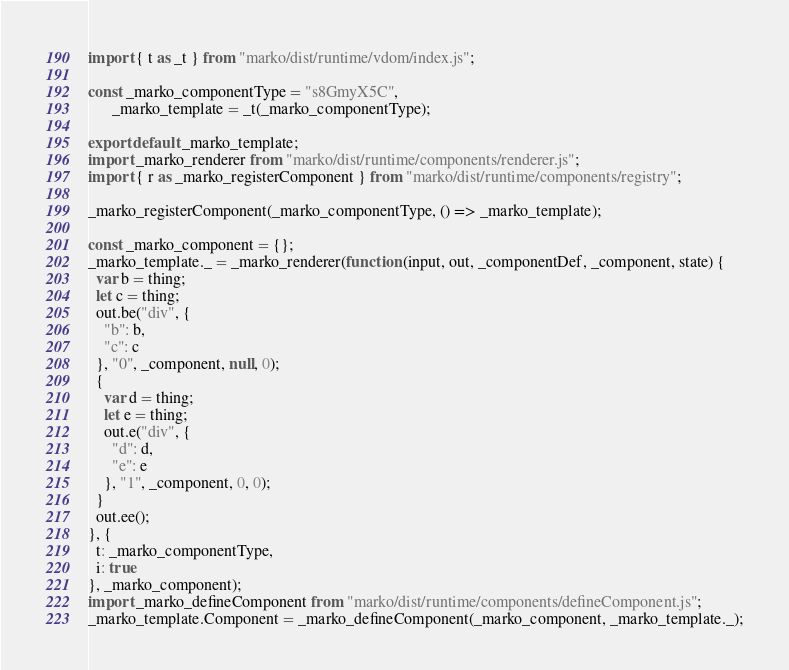Convert code to text. <code><loc_0><loc_0><loc_500><loc_500><_JavaScript_>import { t as _t } from "marko/dist/runtime/vdom/index.js";

const _marko_componentType = "s8GmyX5C",
      _marko_template = _t(_marko_componentType);

export default _marko_template;
import _marko_renderer from "marko/dist/runtime/components/renderer.js";
import { r as _marko_registerComponent } from "marko/dist/runtime/components/registry";

_marko_registerComponent(_marko_componentType, () => _marko_template);

const _marko_component = {};
_marko_template._ = _marko_renderer(function (input, out, _componentDef, _component, state) {
  var b = thing;
  let c = thing;
  out.be("div", {
    "b": b,
    "c": c
  }, "0", _component, null, 0);
  {
    var d = thing;
    let e = thing;
    out.e("div", {
      "d": d,
      "e": e
    }, "1", _component, 0, 0);
  }
  out.ee();
}, {
  t: _marko_componentType,
  i: true
}, _marko_component);
import _marko_defineComponent from "marko/dist/runtime/components/defineComponent.js";
_marko_template.Component = _marko_defineComponent(_marko_component, _marko_template._);</code> 